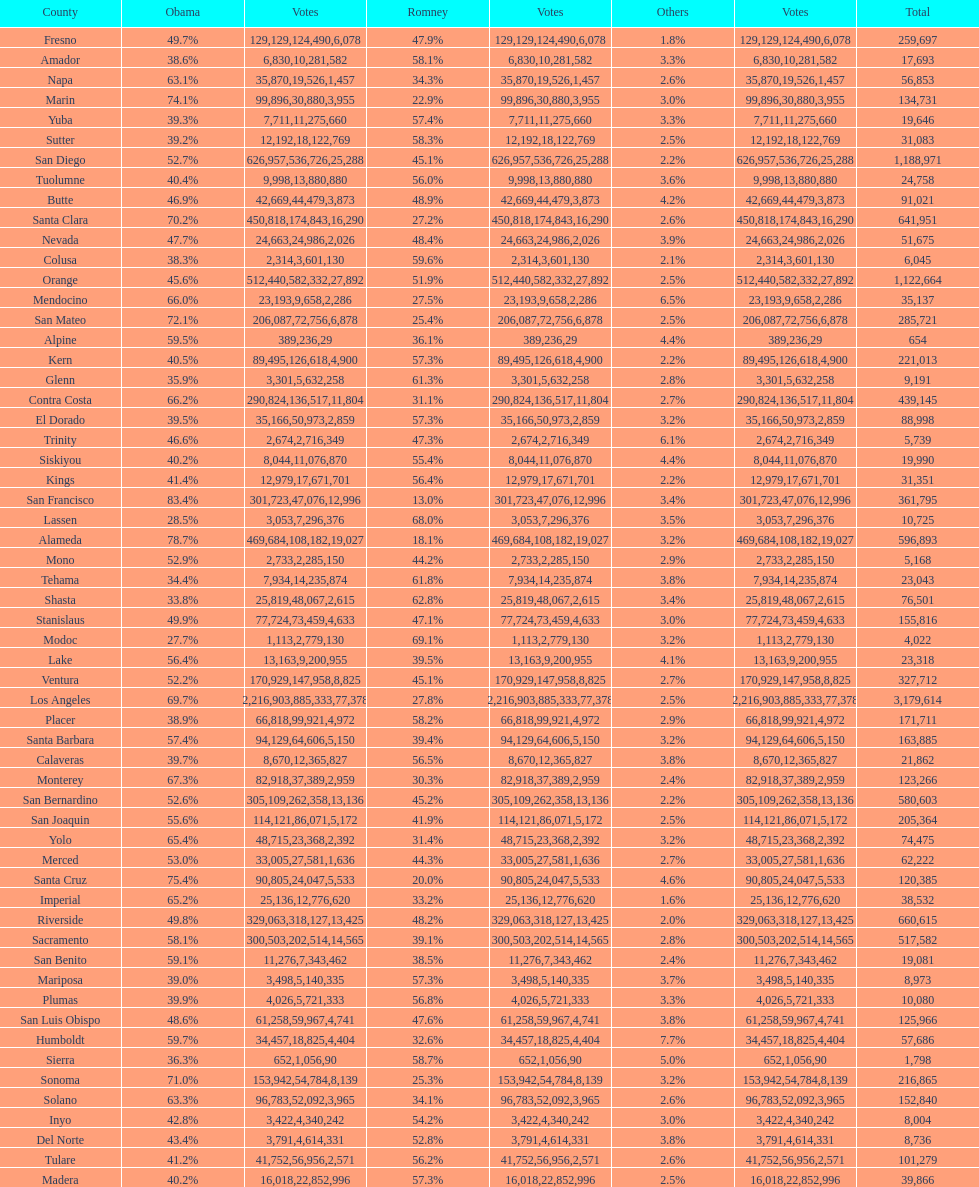What is the total number of votes for amador? 17693. 